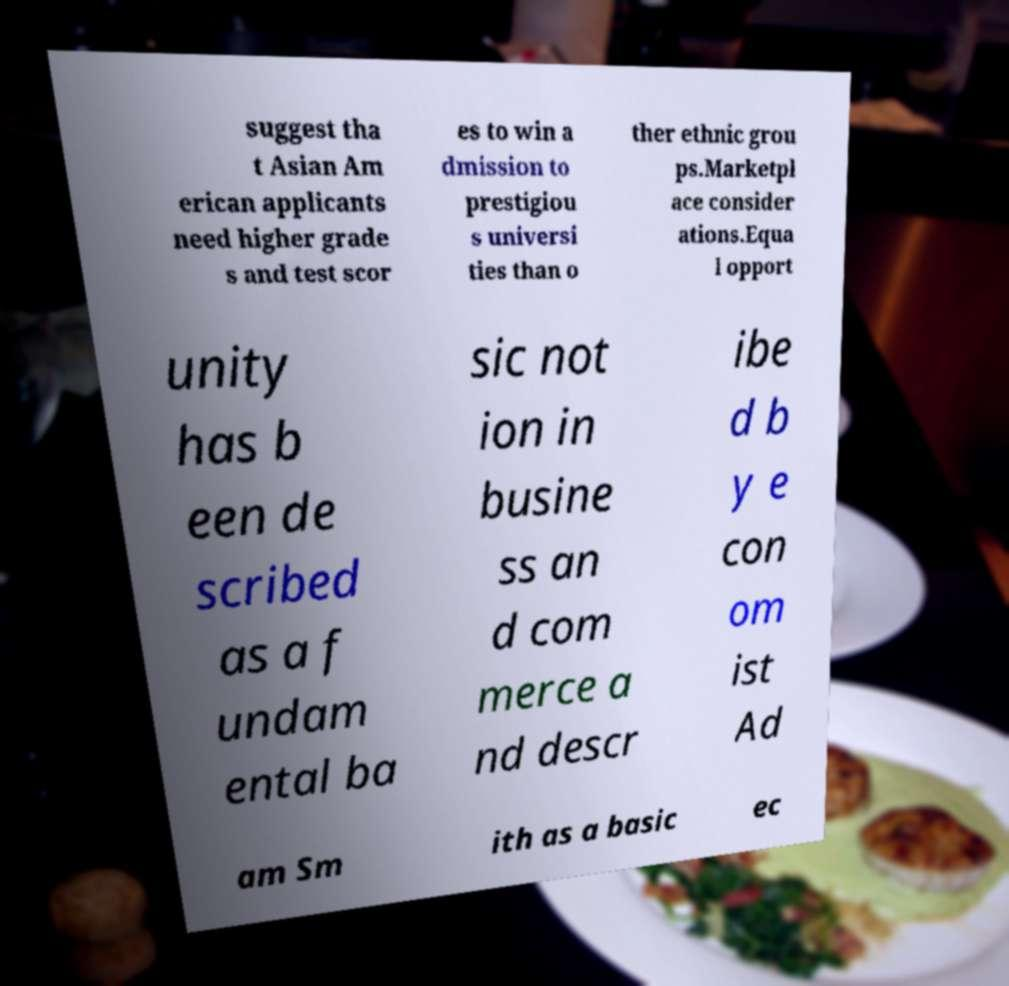What messages or text are displayed in this image? I need them in a readable, typed format. suggest tha t Asian Am erican applicants need higher grade s and test scor es to win a dmission to prestigiou s universi ties than o ther ethnic grou ps.Marketpl ace consider ations.Equa l opport unity has b een de scribed as a f undam ental ba sic not ion in busine ss an d com merce a nd descr ibe d b y e con om ist Ad am Sm ith as a basic ec 